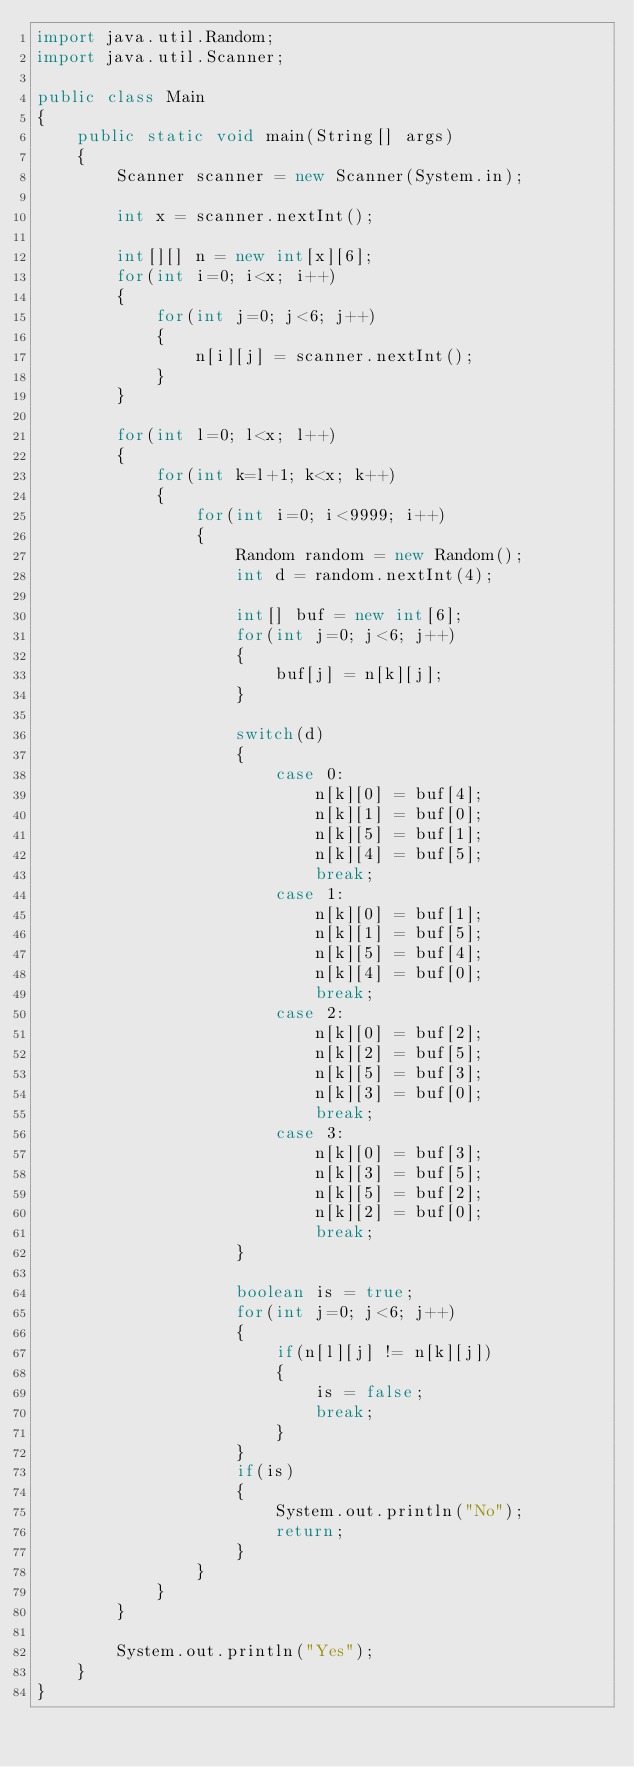<code> <loc_0><loc_0><loc_500><loc_500><_Java_>import java.util.Random;
import java.util.Scanner;

public class Main 
{	
	public static void main(String[] args)
	{
		Scanner scanner = new Scanner(System.in);

		int x = scanner.nextInt();
		
		int[][] n = new int[x][6];
		for(int i=0; i<x; i++)
		{
			for(int j=0; j<6; j++)
			{
				n[i][j] = scanner.nextInt();
			}
		}
		
		for(int l=0; l<x; l++)
		{
			for(int k=l+1; k<x; k++)
			{
				for(int i=0; i<9999; i++)
				{
					Random random = new Random();
					int d = random.nextInt(4);
						
					int[] buf = new int[6];
					for(int j=0; j<6; j++)
					{
						buf[j] = n[k][j];
					}
							
					switch(d)
					{
						case 0:
							n[k][0] = buf[4];
							n[k][1] = buf[0];
							n[k][5] = buf[1];
							n[k][4] = buf[5];
							break;
						case 1:
							n[k][0] = buf[1];
							n[k][1] = buf[5];
							n[k][5] = buf[4];
							n[k][4] = buf[0];
							break;
						case 2:
							n[k][0] = buf[2];
							n[k][2] = buf[5];
							n[k][5] = buf[3];
							n[k][3] = buf[0];
							break;
						case 3:
							n[k][0] = buf[3];
							n[k][3] = buf[5];
							n[k][5] = buf[2];
							n[k][2] = buf[0];
							break;
					}
					
					boolean is = true;
					for(int j=0; j<6; j++)
					{
						if(n[l][j] != n[k][j])
						{
							is = false;
							break;
						}
					}
					if(is)
					{
						System.out.println("No");
						return;
					}
				}
			}
		}
		
		System.out.println("Yes");
	}
}</code> 